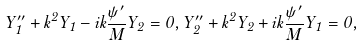<formula> <loc_0><loc_0><loc_500><loc_500>Y _ { 1 } ^ { \prime \prime } + k ^ { 2 } Y _ { 1 } - i k \frac { \psi ^ { \prime } } { M } Y _ { 2 } = 0 , Y _ { 2 } ^ { \prime \prime } + k ^ { 2 } Y _ { 2 } + i k \frac { \psi ^ { \prime } } { M } Y _ { 1 } = 0 ,</formula> 